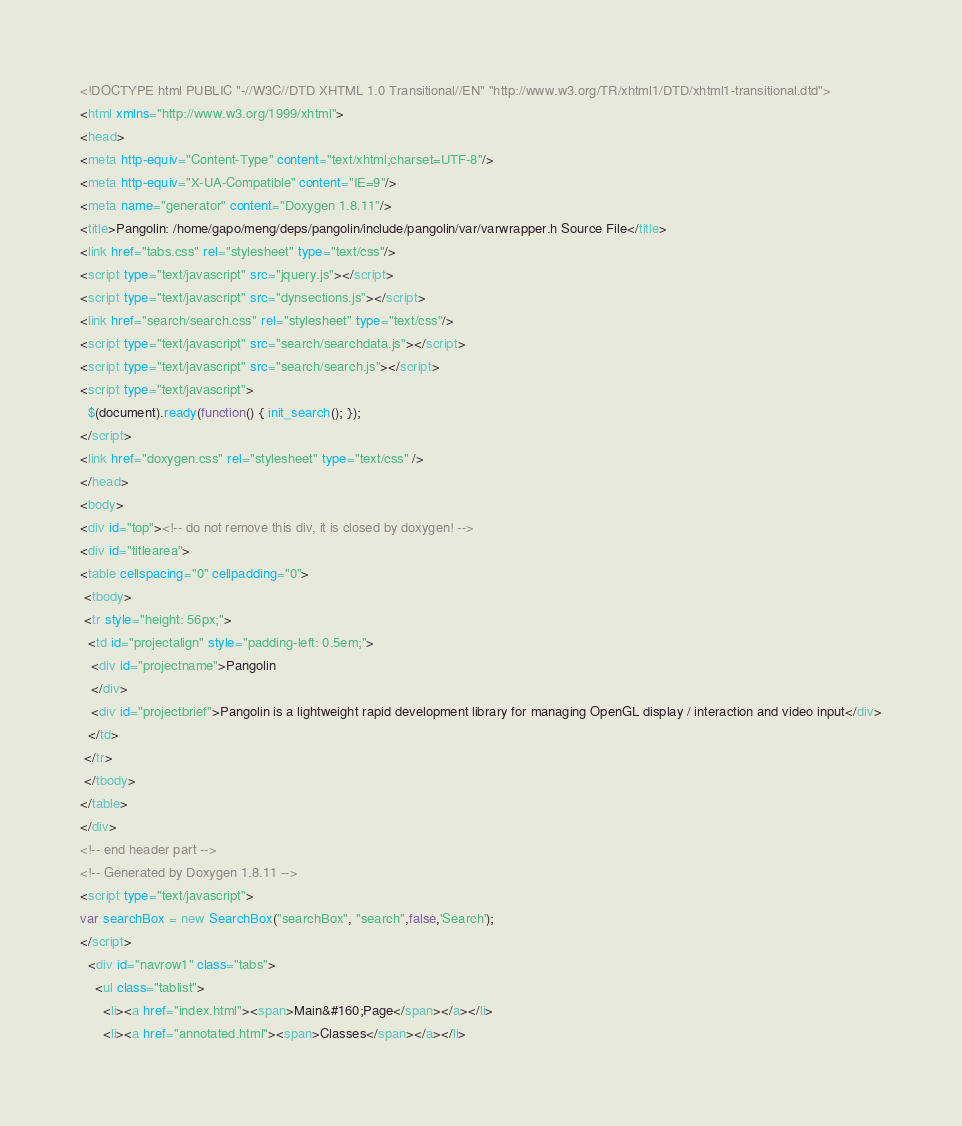<code> <loc_0><loc_0><loc_500><loc_500><_HTML_><!DOCTYPE html PUBLIC "-//W3C//DTD XHTML 1.0 Transitional//EN" "http://www.w3.org/TR/xhtml1/DTD/xhtml1-transitional.dtd">
<html xmlns="http://www.w3.org/1999/xhtml">
<head>
<meta http-equiv="Content-Type" content="text/xhtml;charset=UTF-8"/>
<meta http-equiv="X-UA-Compatible" content="IE=9"/>
<meta name="generator" content="Doxygen 1.8.11"/>
<title>Pangolin: /home/gapo/meng/deps/pangolin/include/pangolin/var/varwrapper.h Source File</title>
<link href="tabs.css" rel="stylesheet" type="text/css"/>
<script type="text/javascript" src="jquery.js"></script>
<script type="text/javascript" src="dynsections.js"></script>
<link href="search/search.css" rel="stylesheet" type="text/css"/>
<script type="text/javascript" src="search/searchdata.js"></script>
<script type="text/javascript" src="search/search.js"></script>
<script type="text/javascript">
  $(document).ready(function() { init_search(); });
</script>
<link href="doxygen.css" rel="stylesheet" type="text/css" />
</head>
<body>
<div id="top"><!-- do not remove this div, it is closed by doxygen! -->
<div id="titlearea">
<table cellspacing="0" cellpadding="0">
 <tbody>
 <tr style="height: 56px;">
  <td id="projectalign" style="padding-left: 0.5em;">
   <div id="projectname">Pangolin
   </div>
   <div id="projectbrief">Pangolin is a lightweight rapid development library for managing OpenGL display / interaction and video input</div>
  </td>
 </tr>
 </tbody>
</table>
</div>
<!-- end header part -->
<!-- Generated by Doxygen 1.8.11 -->
<script type="text/javascript">
var searchBox = new SearchBox("searchBox", "search",false,'Search');
</script>
  <div id="navrow1" class="tabs">
    <ul class="tablist">
      <li><a href="index.html"><span>Main&#160;Page</span></a></li>
      <li><a href="annotated.html"><span>Classes</span></a></li></code> 